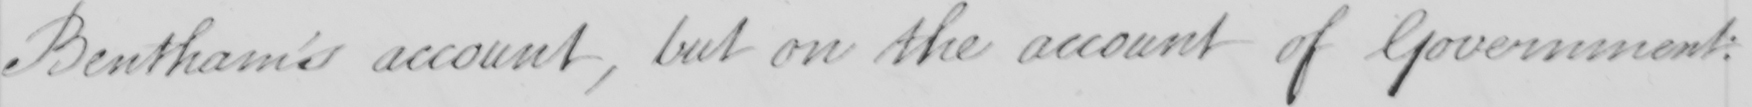What text is written in this handwritten line? Bentham's account, but on the account of Government: 